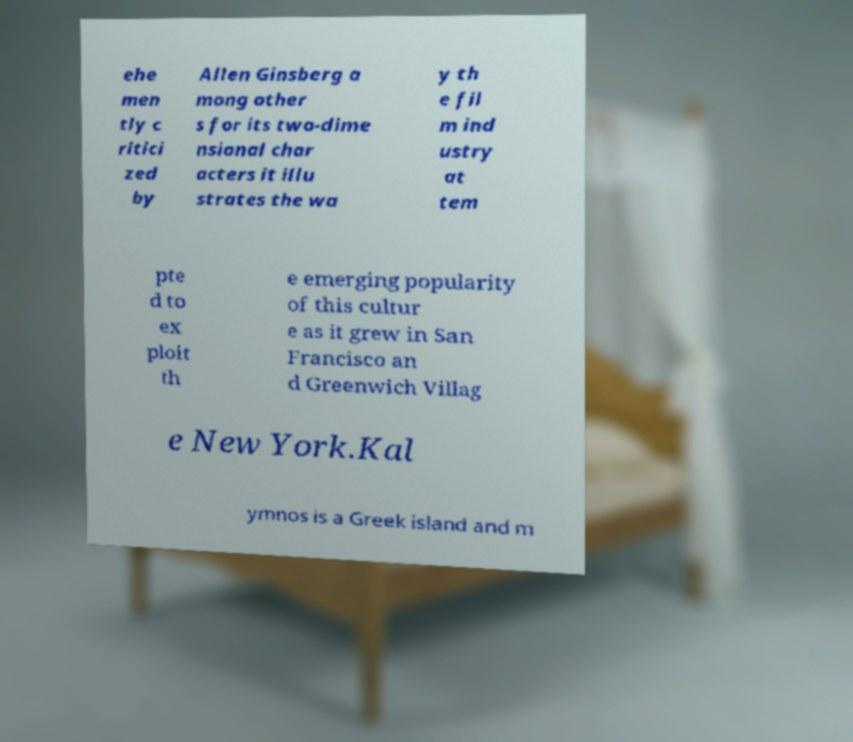Could you assist in decoding the text presented in this image and type it out clearly? ehe men tly c ritici zed by Allen Ginsberg a mong other s for its two-dime nsional char acters it illu strates the wa y th e fil m ind ustry at tem pte d to ex ploit th e emerging popularity of this cultur e as it grew in San Francisco an d Greenwich Villag e New York.Kal ymnos is a Greek island and m 